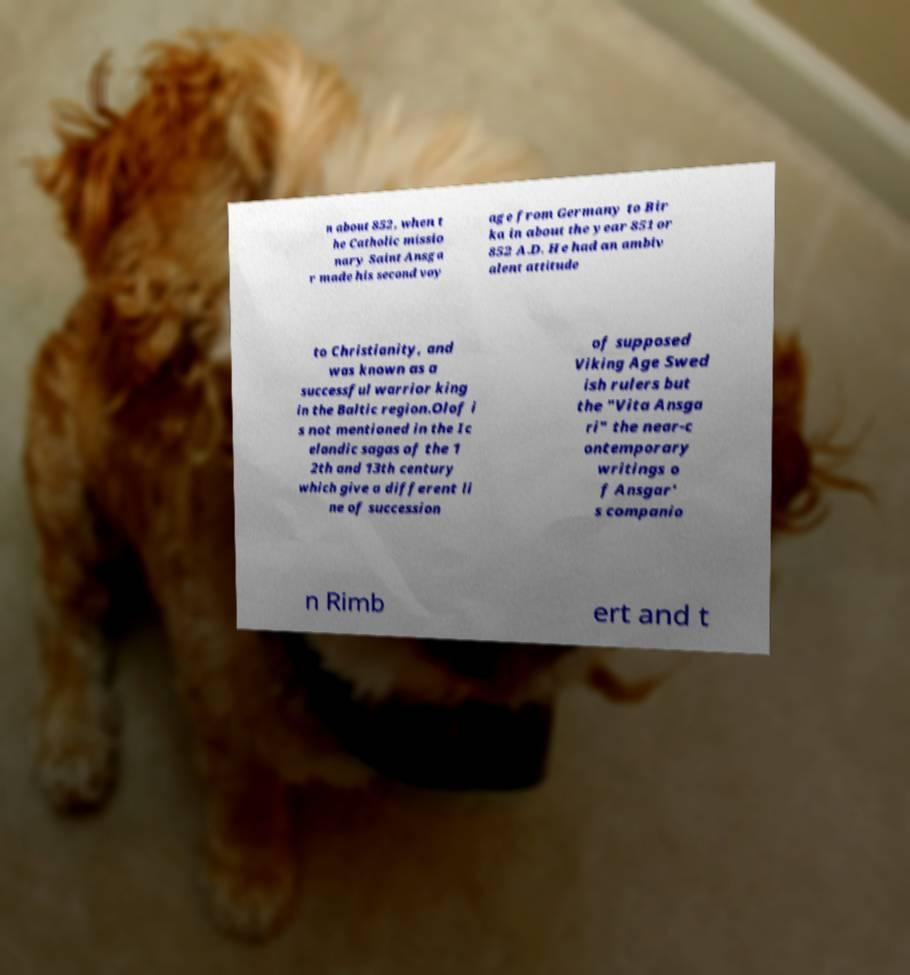There's text embedded in this image that I need extracted. Can you transcribe it verbatim? n about 852, when t he Catholic missio nary Saint Ansga r made his second voy age from Germany to Bir ka in about the year 851 or 852 A.D. He had an ambiv alent attitude to Christianity, and was known as a successful warrior king in the Baltic region.Olof i s not mentioned in the Ic elandic sagas of the 1 2th and 13th century which give a different li ne of succession of supposed Viking Age Swed ish rulers but the "Vita Ansga ri" the near-c ontemporary writings o f Ansgar' s companio n Rimb ert and t 